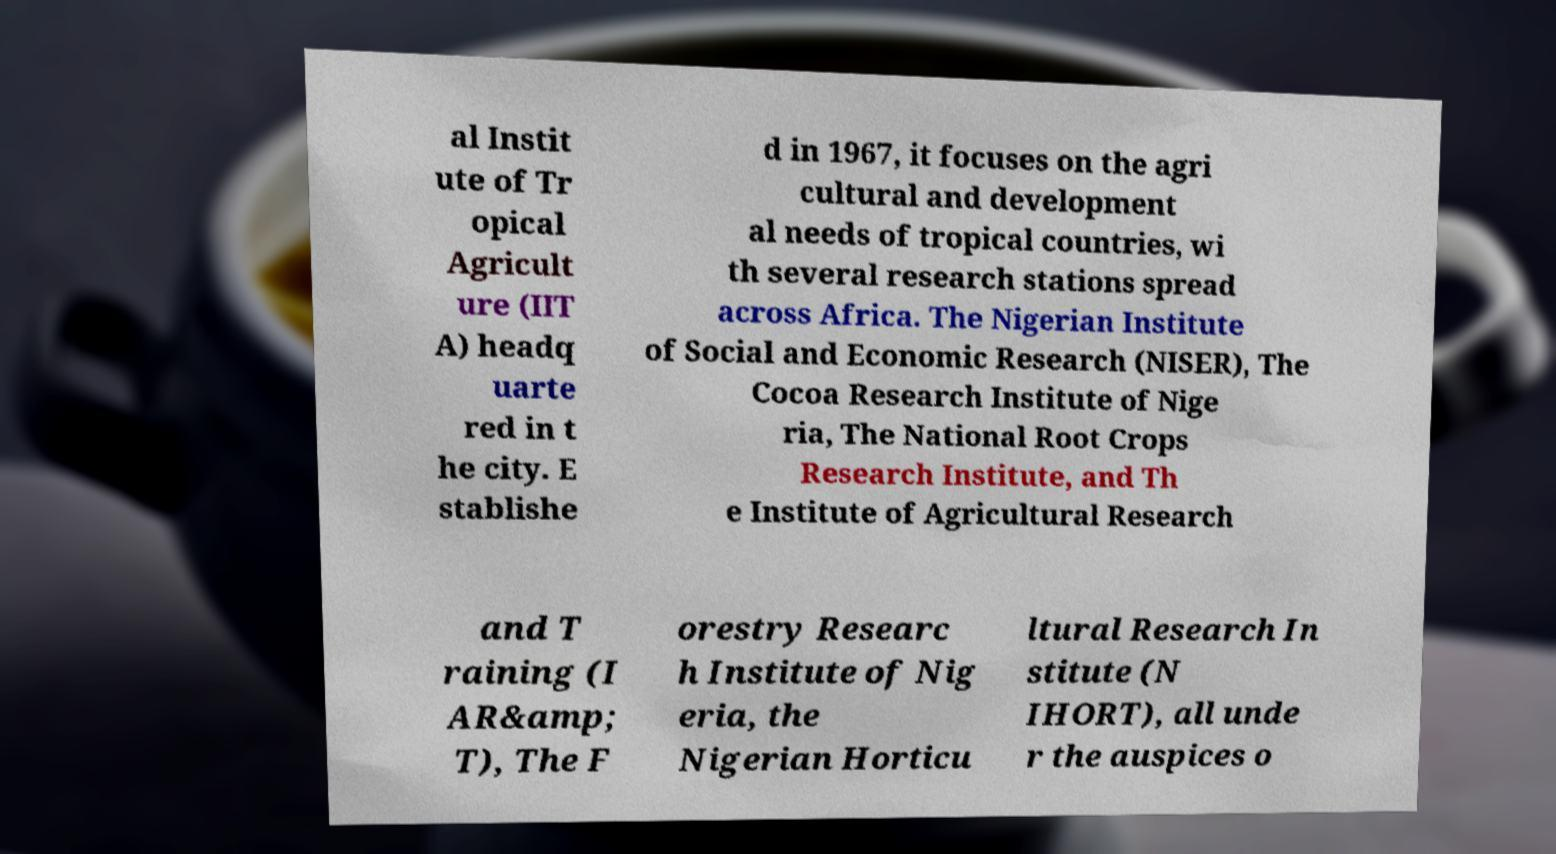Could you extract and type out the text from this image? al Instit ute of Tr opical Agricult ure (IIT A) headq uarte red in t he city. E stablishe d in 1967, it focuses on the agri cultural and development al needs of tropical countries, wi th several research stations spread across Africa. The Nigerian Institute of Social and Economic Research (NISER), The Cocoa Research Institute of Nige ria, The National Root Crops Research Institute, and Th e Institute of Agricultural Research and T raining (I AR&amp; T), The F orestry Researc h Institute of Nig eria, the Nigerian Horticu ltural Research In stitute (N IHORT), all unde r the auspices o 